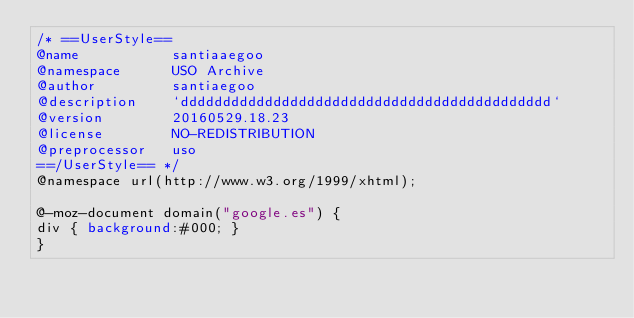<code> <loc_0><loc_0><loc_500><loc_500><_CSS_>/* ==UserStyle==
@name           santiaaegoo
@namespace      USO Archive
@author         santiaegoo
@description    `dddddddddddddddddddddddddddddddddddddddddddd`
@version        20160529.18.23
@license        NO-REDISTRIBUTION
@preprocessor   uso
==/UserStyle== */
@namespace url(http://www.w3.org/1999/xhtml);

@-moz-document domain("google.es") {
div { background:#000; }
}</code> 